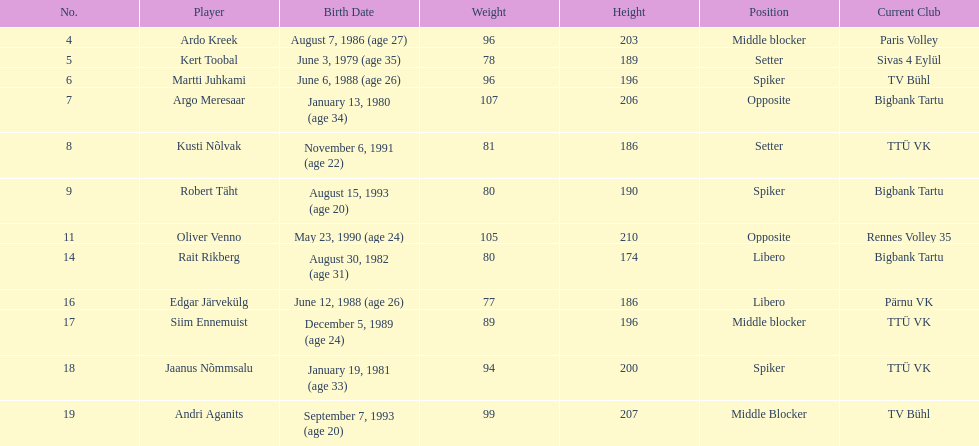Among estonia's men's national volleyball team members, who has the greatest height? Oliver Venno. 